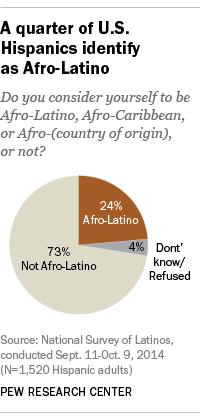Give some essential details in this illustration. The smallest segment of the graph is colored gray. 